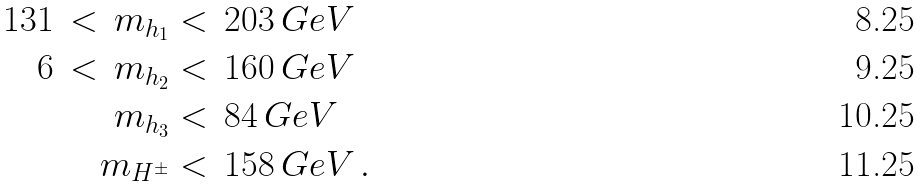Convert formula to latex. <formula><loc_0><loc_0><loc_500><loc_500>1 3 1 \, < \, m _ { h _ { 1 } } & < \, 2 0 3 \, G e V \\ 6 \, < \, m _ { h _ { 2 } } & < \, 1 6 0 \, G e V \\ m _ { h _ { 3 } } & < \, 8 4 \, G e V \\ m _ { H ^ { \pm } } & < \, 1 5 8 \, G e V \, .</formula> 